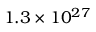Convert formula to latex. <formula><loc_0><loc_0><loc_500><loc_500>1 . 3 \times 1 0 ^ { 2 7 }</formula> 